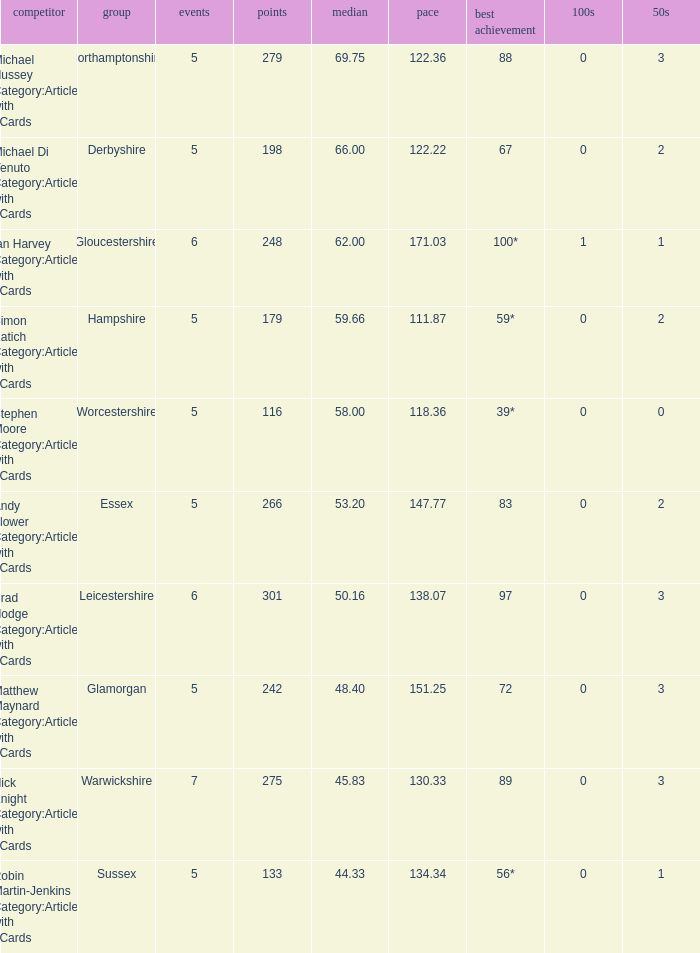What is the team Sussex' highest score? 56*. 